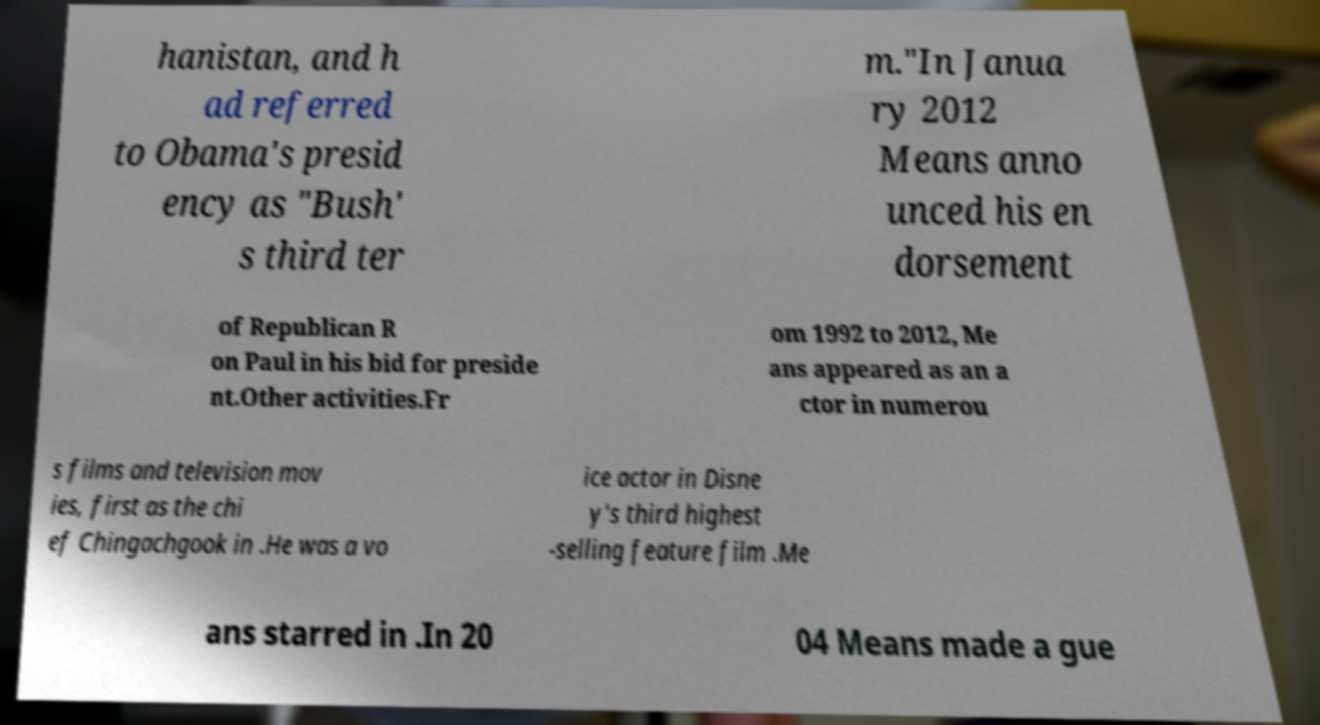Please identify and transcribe the text found in this image. hanistan, and h ad referred to Obama's presid ency as "Bush' s third ter m."In Janua ry 2012 Means anno unced his en dorsement of Republican R on Paul in his bid for preside nt.Other activities.Fr om 1992 to 2012, Me ans appeared as an a ctor in numerou s films and television mov ies, first as the chi ef Chingachgook in .He was a vo ice actor in Disne y's third highest -selling feature film .Me ans starred in .In 20 04 Means made a gue 